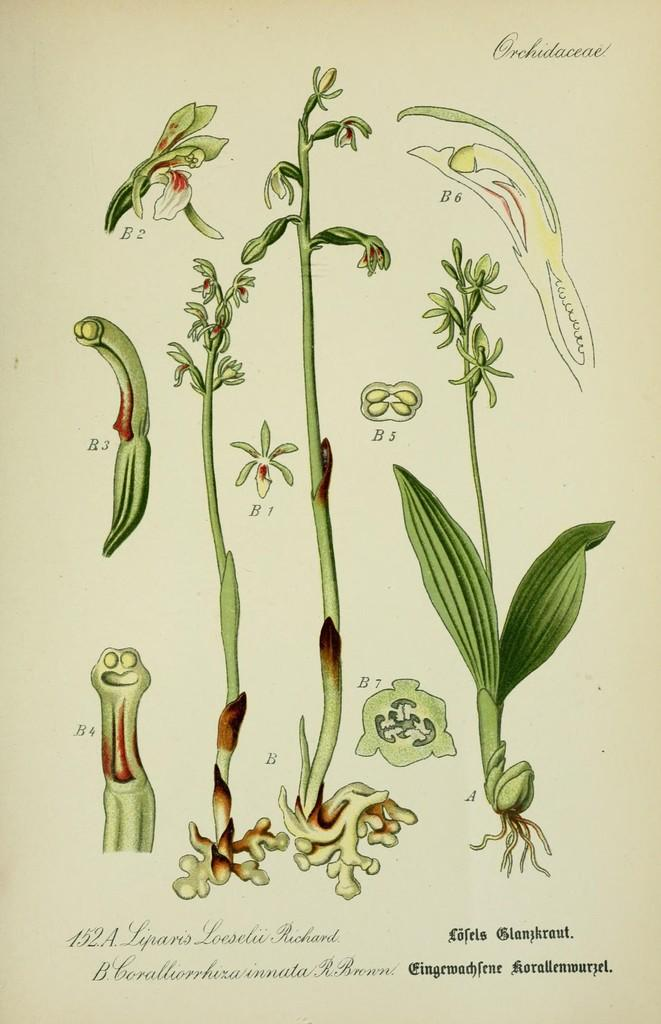What types of living organisms can be seen in the image? There are different plant species in the image. Is there any text present in the image? Yes, there is text written at the bottom of the image. How many blades are visible in the image? There are no blades present in the image; it features different plant species. What type of behavior can be observed in the geese in the image? There are no geese present in the image, so their behavior cannot be observed. 